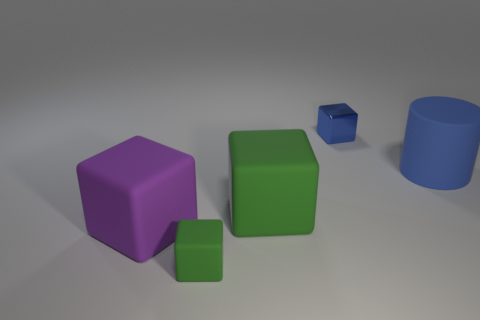How many green cubes must be subtracted to get 1 green cubes? 1 Subtract all cubes. How many objects are left? 1 Add 3 purple matte objects. How many objects exist? 8 Subtract all green blocks. How many blocks are left? 2 Subtract all tiny blue shiny blocks. How many blocks are left? 3 Subtract 2 blocks. How many blocks are left? 2 Add 2 tiny blue cubes. How many tiny blue cubes exist? 3 Subtract 0 purple balls. How many objects are left? 5 Subtract all brown blocks. Subtract all gray cylinders. How many blocks are left? 4 Subtract all yellow cylinders. How many green cubes are left? 2 